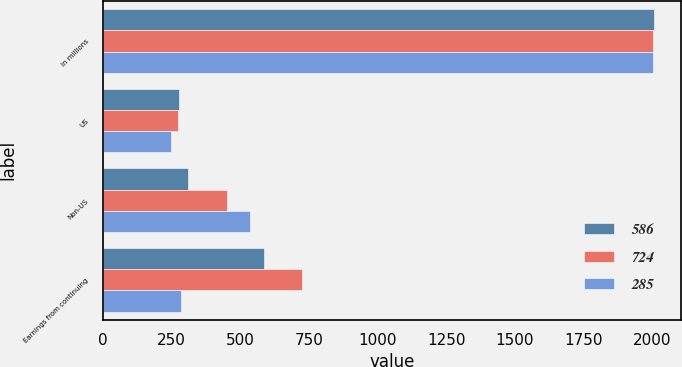<chart> <loc_0><loc_0><loc_500><loc_500><stacked_bar_chart><ecel><fcel>In millions<fcel>US<fcel>Non-US<fcel>Earnings from continuing<nl><fcel>586<fcel>2005<fcel>276<fcel>310<fcel>586<nl><fcel>724<fcel>2004<fcel>271<fcel>453<fcel>724<nl><fcel>285<fcel>2003<fcel>249<fcel>534<fcel>285<nl></chart> 